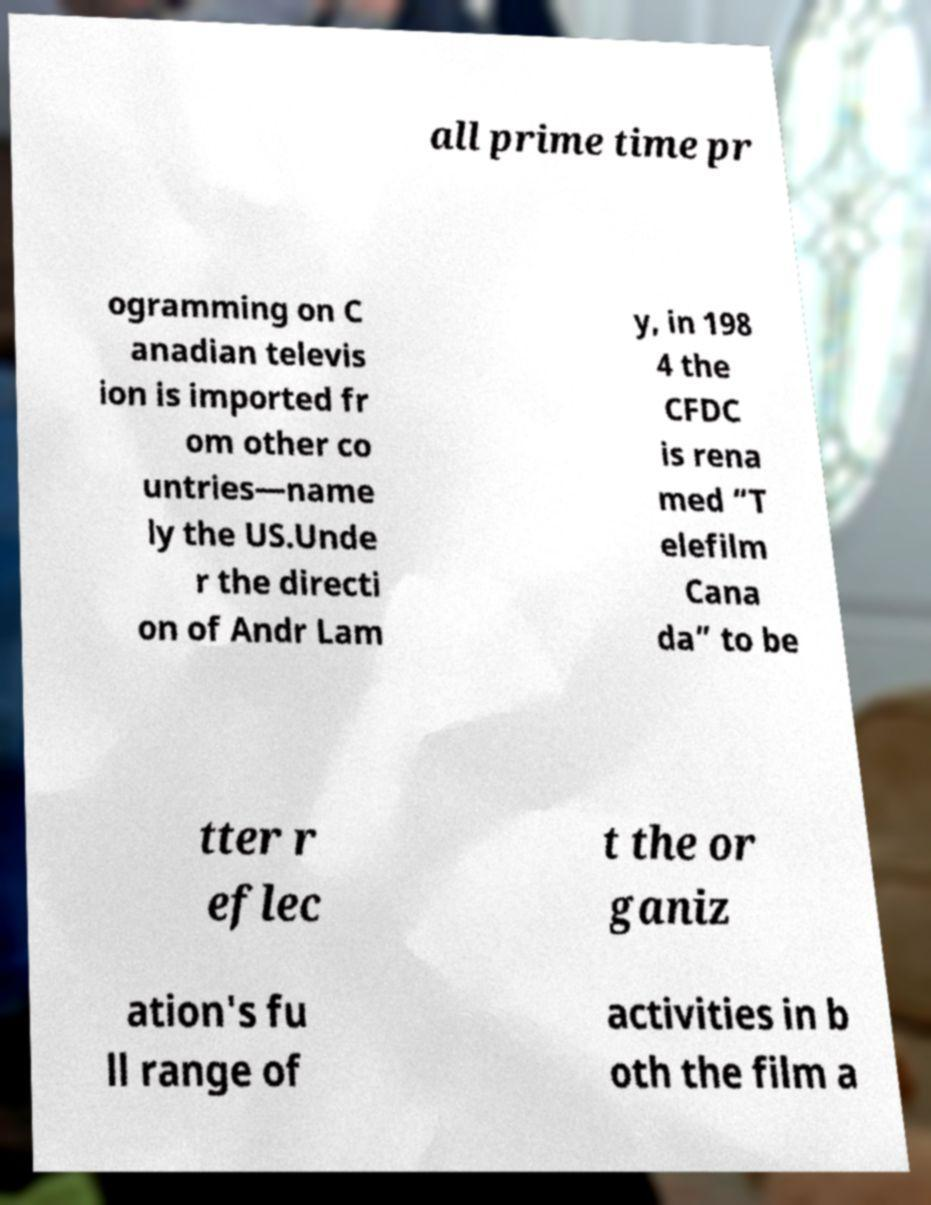There's text embedded in this image that I need extracted. Can you transcribe it verbatim? all prime time pr ogramming on C anadian televis ion is imported fr om other co untries—name ly the US.Unde r the directi on of Andr Lam y, in 198 4 the CFDC is rena med “T elefilm Cana da” to be tter r eflec t the or ganiz ation's fu ll range of activities in b oth the film a 